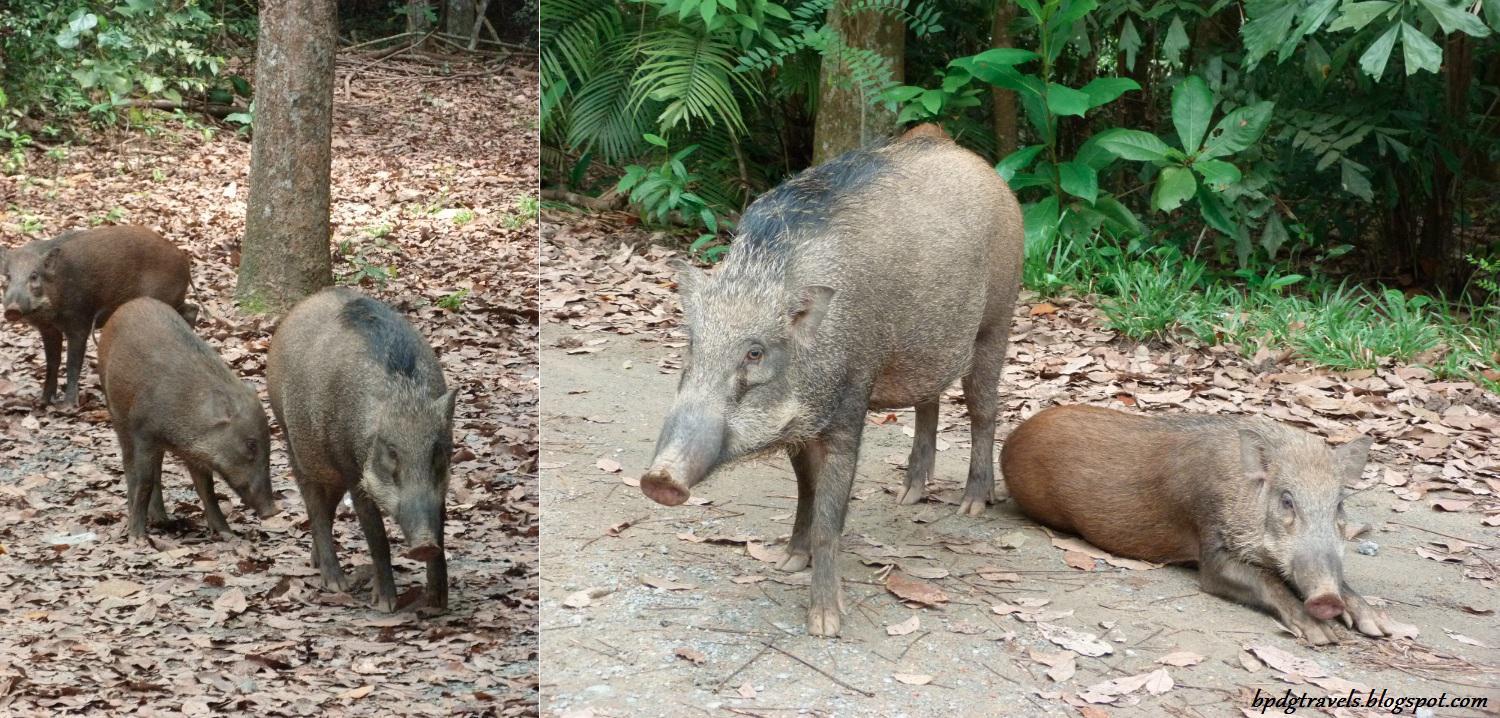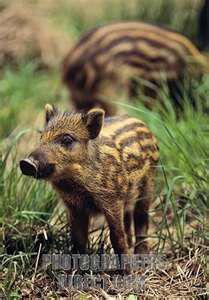The first image is the image on the left, the second image is the image on the right. Analyze the images presented: Is the assertion "An image contains exactly two pigs, which are striped juveniles." valid? Answer yes or no. Yes. The first image is the image on the left, the second image is the image on the right. Examine the images to the left and right. Is the description "At least one of the animals in the image on the right has its mouth open." accurate? Answer yes or no. No. 